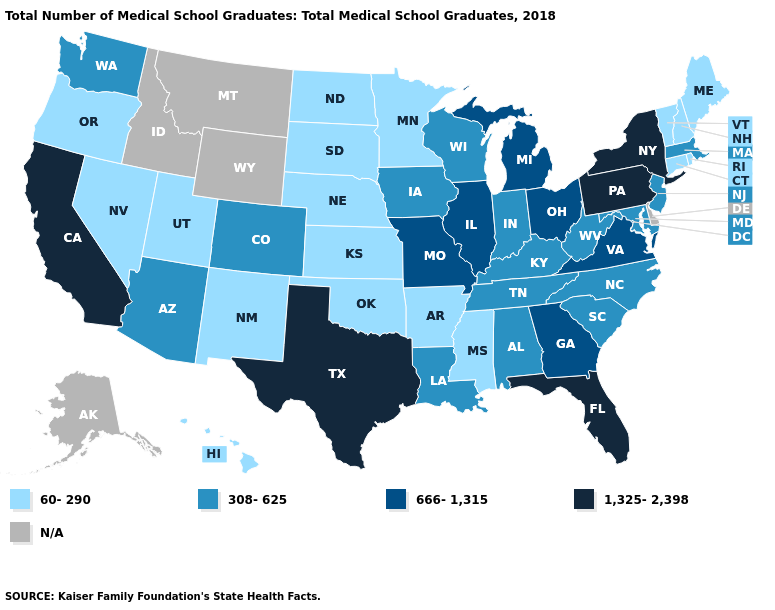Name the states that have a value in the range 666-1,315?
Short answer required. Georgia, Illinois, Michigan, Missouri, Ohio, Virginia. Name the states that have a value in the range 1,325-2,398?
Concise answer only. California, Florida, New York, Pennsylvania, Texas. What is the value of Pennsylvania?
Be succinct. 1,325-2,398. What is the highest value in the USA?
Be succinct. 1,325-2,398. What is the value of Maryland?
Short answer required. 308-625. What is the value of Virginia?
Keep it brief. 666-1,315. What is the value of New Jersey?
Short answer required. 308-625. What is the value of Montana?
Quick response, please. N/A. Which states have the lowest value in the West?
Quick response, please. Hawaii, Nevada, New Mexico, Oregon, Utah. Among the states that border Iowa , which have the lowest value?
Concise answer only. Minnesota, Nebraska, South Dakota. Does the first symbol in the legend represent the smallest category?
Give a very brief answer. Yes. How many symbols are there in the legend?
Concise answer only. 5. How many symbols are there in the legend?
Keep it brief. 5. Which states have the lowest value in the West?
Be succinct. Hawaii, Nevada, New Mexico, Oregon, Utah. Does the map have missing data?
Concise answer only. Yes. 